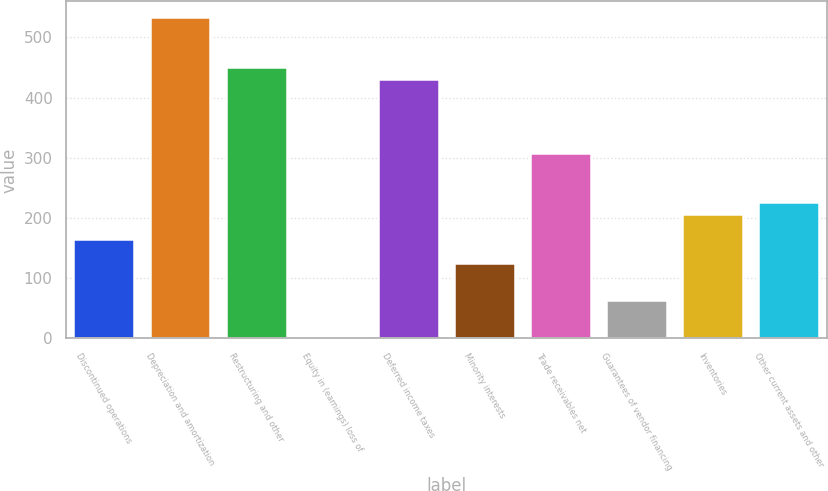Convert chart to OTSL. <chart><loc_0><loc_0><loc_500><loc_500><bar_chart><fcel>Discontinued operations<fcel>Depreciation and amortization<fcel>Restructuring and other<fcel>Equity in (earnings) loss of<fcel>Deferred income taxes<fcel>Minority interests<fcel>Trade receivables net<fcel>Guarantees of vendor financing<fcel>Inventories<fcel>Other current assets and other<nl><fcel>165.58<fcel>532.96<fcel>451.32<fcel>2.3<fcel>430.91<fcel>124.76<fcel>308.45<fcel>63.53<fcel>206.4<fcel>226.81<nl></chart> 